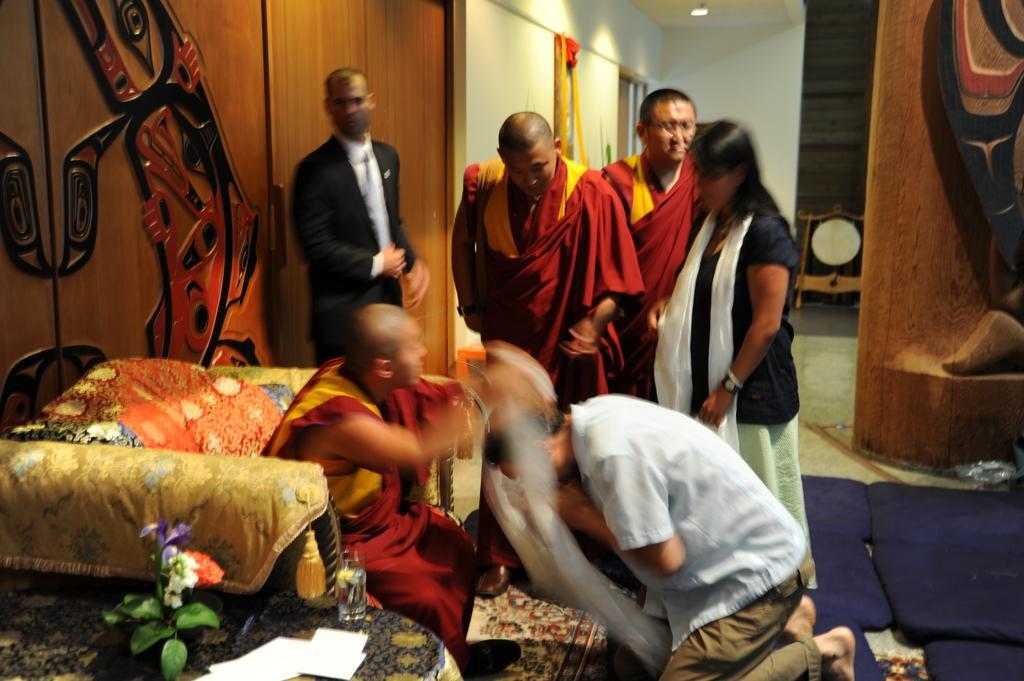Could you give a brief overview of what you see in this image? In this picture there is a man wearing blue color shirt sitting down in the front of the Buddhist priest who is sitting on the sofa. Behind there are two Buddhist priest standing and a lady wearing a black shirt standing beside them. In the background we can see wooden wardrobes and white wall. In the front bottom side there is a center table and water glass. 